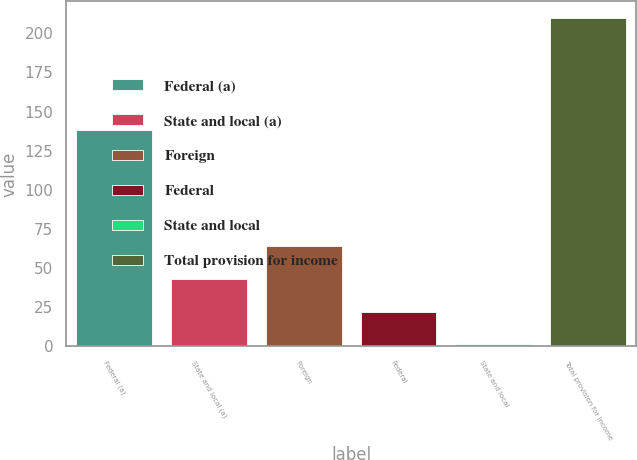Convert chart. <chart><loc_0><loc_0><loc_500><loc_500><bar_chart><fcel>Federal (a)<fcel>State and local (a)<fcel>Foreign<fcel>Federal<fcel>State and local<fcel>Total provision for income<nl><fcel>138<fcel>43.08<fcel>63.92<fcel>22.24<fcel>1.4<fcel>209.8<nl></chart> 